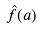<formula> <loc_0><loc_0><loc_500><loc_500>\hat { f } ( a )</formula> 